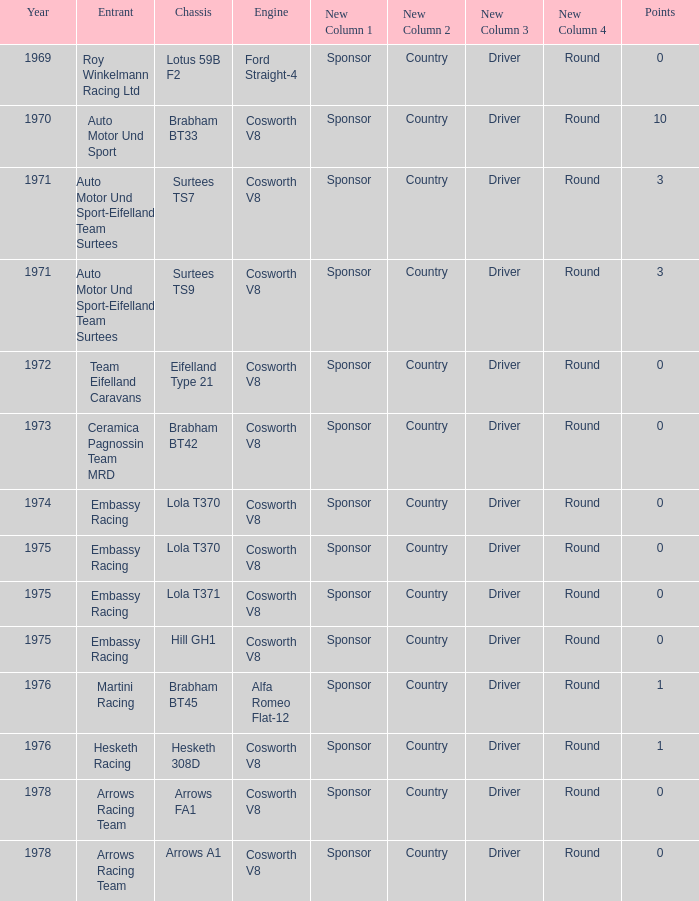Who was the entrant in 1971? Auto Motor Und Sport-Eifelland Team Surtees, Auto Motor Und Sport-Eifelland Team Surtees. 